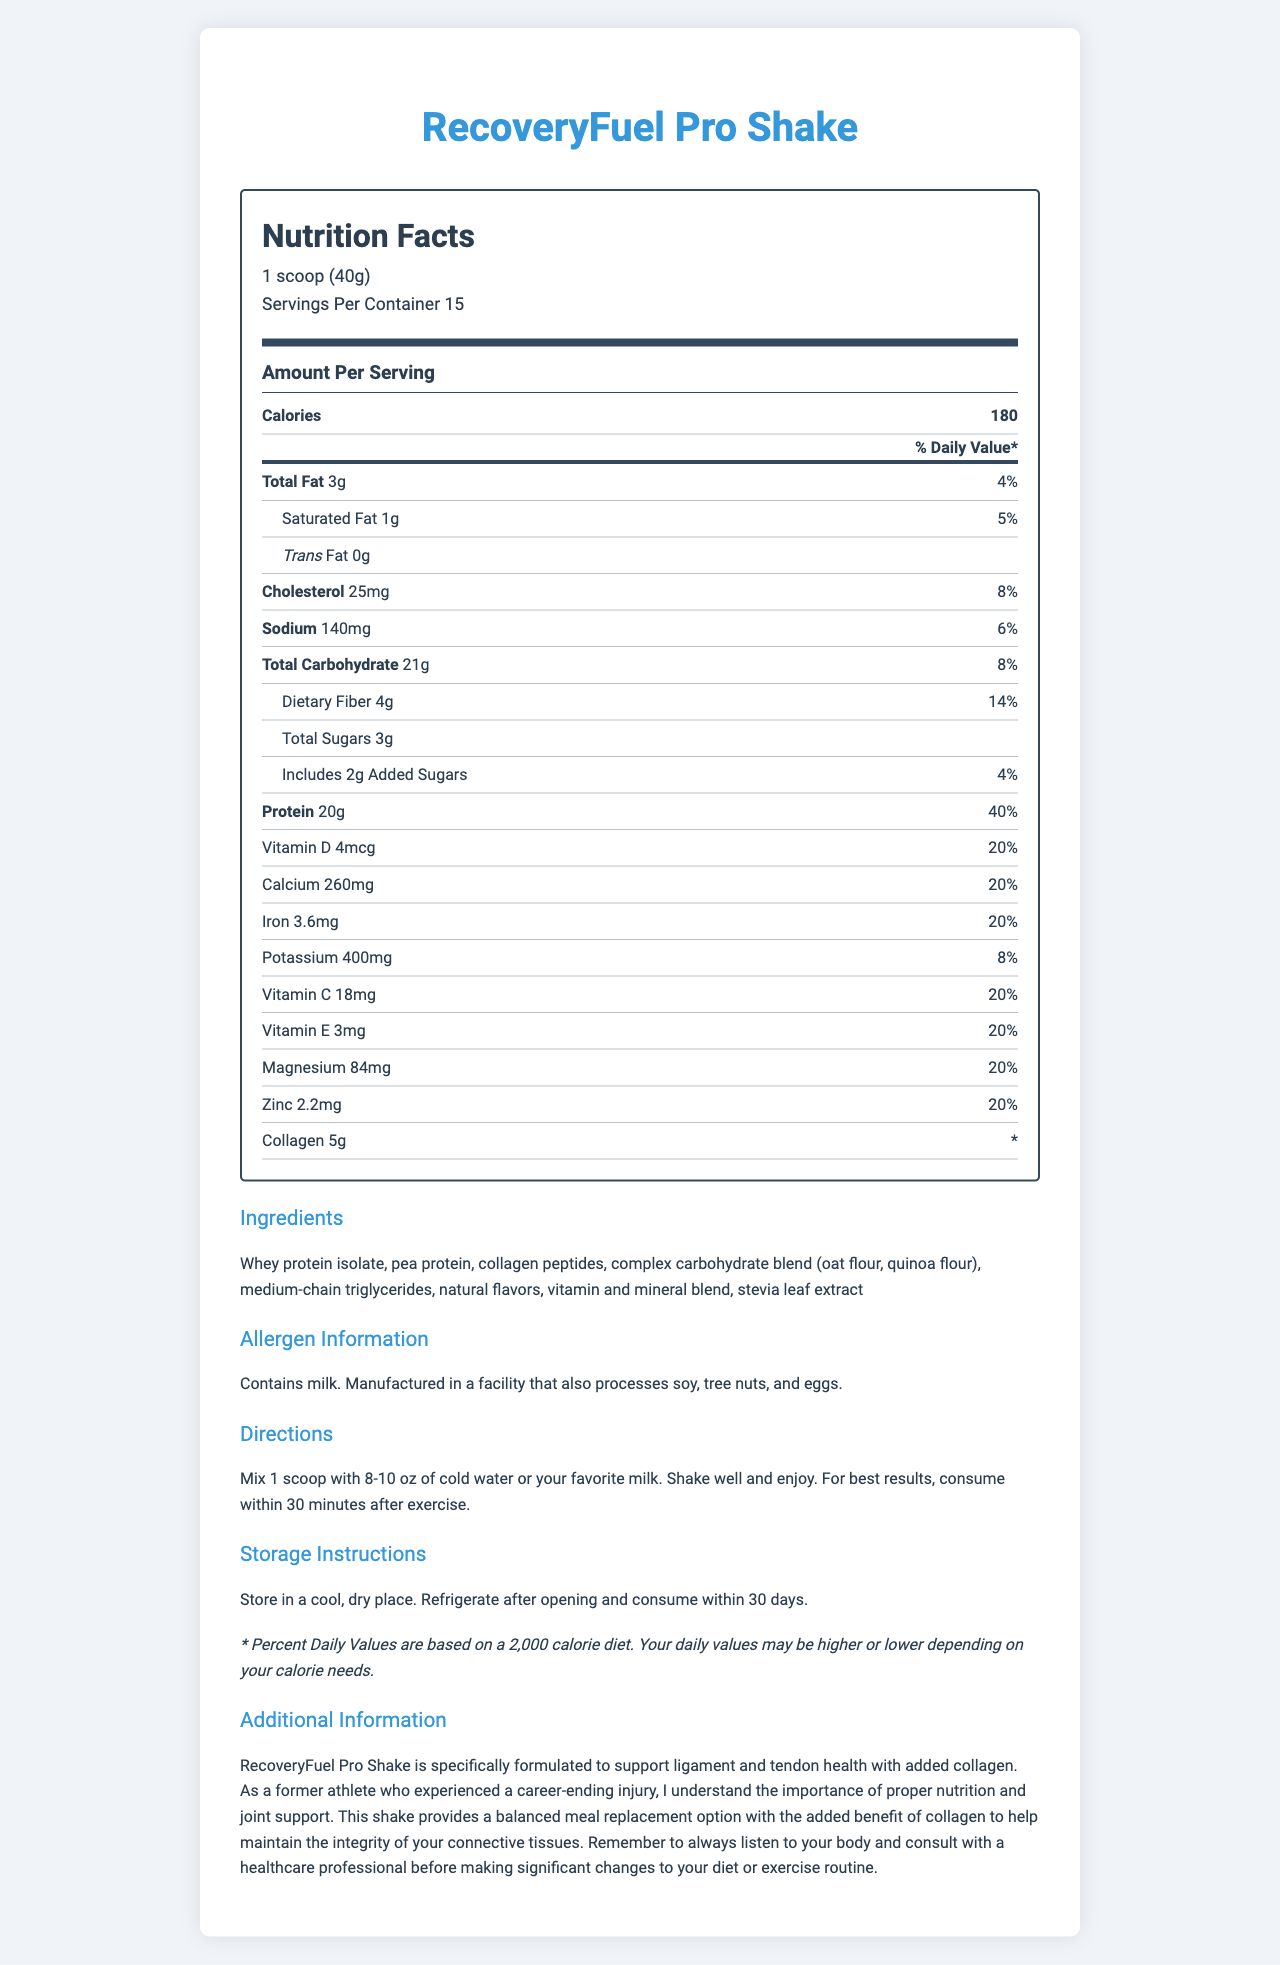what is the product name? The product name is clearly stated at the top of the document.
Answer: RecoveryFuel Pro Shake how many servings are in the container? The document mentions "Servings Per Container 15" in the Nutrition Facts section.
Answer: 15 how much protein is in one serving of the shake? The document states that each serving contains 20g of protein with a percent daily value of 40%.
Answer: 20g what is the main purpose of this shake? The additional information section details that the shake is specifically formulated to support ligament and tendon health with added collagen.
Answer: To support ligament and tendon health which allergens does this product contain? The allergen information section specifies that the product contains milk and is manufactured in a facility that also processes soy, tree nuts, and eggs.
Answer: Milk how many grams of collagen are in one serving? The document lists "Collagen 5g" in the nutrition label.
Answer: 5g what is the percentage of daily value for vitamin D? The document states that one serving contains 4mcg of vitamin D, which is 20% of the daily value.
Answer: 20% which ingredient is not listed in the document? A. Whey protein isolate B. Collagen peptides C. Soy protein isolate D. Quinoa flour The ingredients section lists whey protein isolate, pea protein, collagen peptides, and quinoa flour, but not soy protein isolate.
Answer: C which of the following statements is true? I. The product contains medium-chain triglycerides. II. The product should be consumed within 30 minutes after exercise. III. The product is free from all allergens. A. Only I B. Only II C. I and II D. I, II, and III The document states the product contains medium-chain triglycerides, and it should be consumed within 30 minutes after exercise. However, it does contain allergens (milk).
Answer: C does this product contain any added sugars? The document indicates that it includes 2g of added sugars.
Answer: Yes is this product suitable for someone with an allergy to eggs? It is not explicitly stated that it is free from egg allergens, and it is manufactured in a facility that processes eggs.
Answer: No summarize the main information provided in the document. The document's goal is to offer a comprehensive overview of the nutritional content, benefits, and usage instructions of the RecoveryFuel Pro Shake, along with pertinent allergen information.
Answer: The document provides detailed nutrition facts for the RecoveryFuel Pro Shake, a balanced meal replacement shake. It highlights the shake's ingredients, allergen information, and instructions for use and storage. Emphasized are the shake's added collagen for ligament and tendon health and the product's suitability as a post-exercise recovery aid. how much vitamin A is in one serving? The document does not provide information about the vitamin A content.
Answer: Cannot be determined 